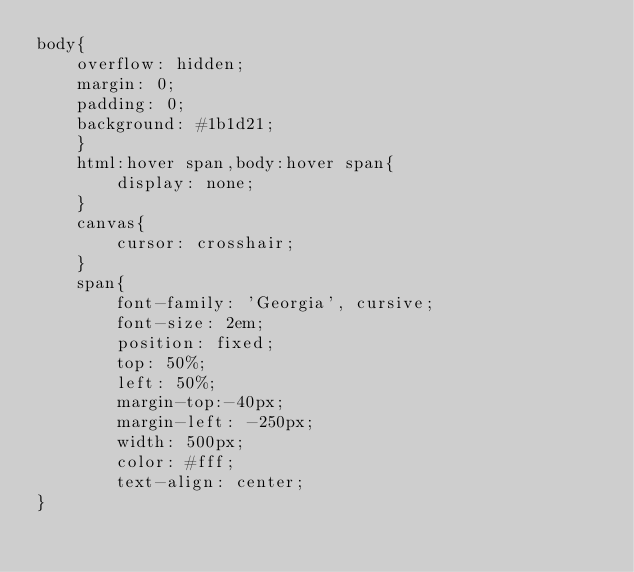<code> <loc_0><loc_0><loc_500><loc_500><_CSS_>body{
    overflow: hidden;
    margin: 0;
    padding: 0;
    background: #1b1d21;
    }
    html:hover span,body:hover span{
        display: none;
    }
    canvas{
        cursor: crosshair;
    }
    span{
        font-family: 'Georgia', cursive;
        font-size: 2em;
        position: fixed;
        top: 50%;
        left: 50%;
        margin-top:-40px;
        margin-left: -250px;
        width: 500px;
        color: #fff;
        text-align: center;
}
</code> 